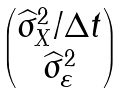<formula> <loc_0><loc_0><loc_500><loc_500>\begin{pmatrix} \widehat { \sigma } ^ { 2 } _ { X } / \Delta t \\ \widehat { \sigma } ^ { 2 } _ { \varepsilon } \end{pmatrix}</formula> 